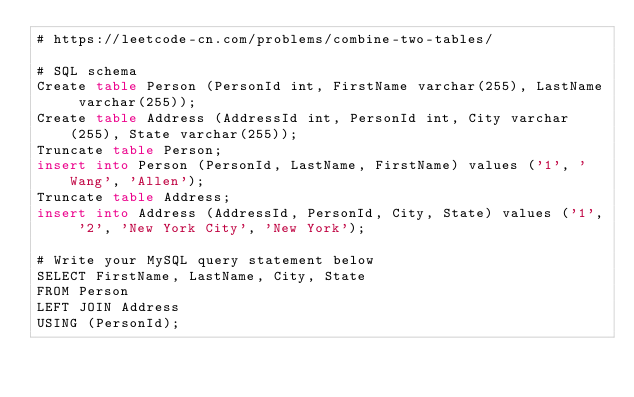<code> <loc_0><loc_0><loc_500><loc_500><_SQL_># https://leetcode-cn.com/problems/combine-two-tables/

# SQL schema
Create table Person (PersonId int, FirstName varchar(255), LastName varchar(255));
Create table Address (AddressId int, PersonId int, City varchar(255), State varchar(255));
Truncate table Person;
insert into Person (PersonId, LastName, FirstName) values ('1', 'Wang', 'Allen');
Truncate table Address;
insert into Address (AddressId, PersonId, City, State) values ('1', '2', 'New York City', 'New York');

# Write your MySQL query statement below
SELECT FirstName, LastName, City, State
FROM Person
LEFT JOIN Address
USING (PersonId);
</code> 